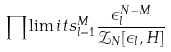<formula> <loc_0><loc_0><loc_500><loc_500>\prod \lim i t s _ { l = 1 } ^ { M } \frac { \epsilon _ { l } ^ { N - M } } { { \mathcal { Z } } _ { N } [ \epsilon _ { l } , H ] }</formula> 